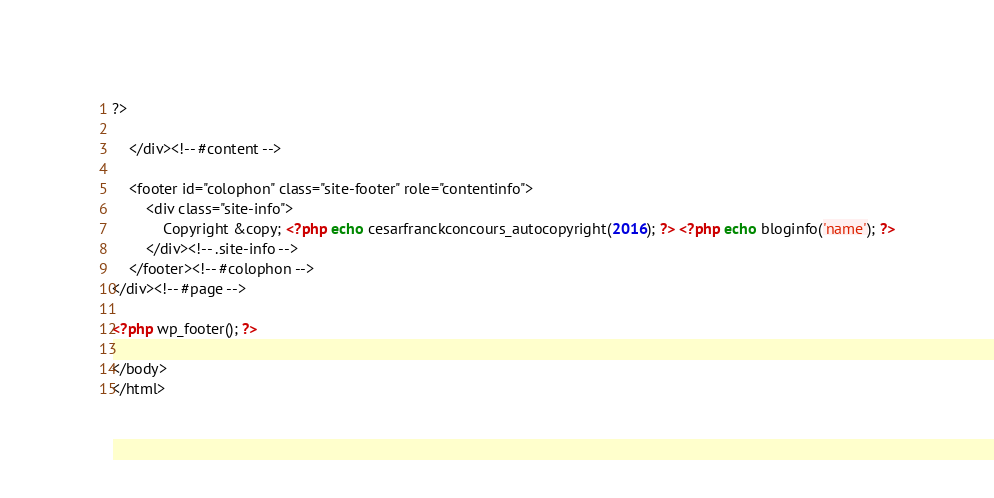Convert code to text. <code><loc_0><loc_0><loc_500><loc_500><_PHP_>
?>

	</div><!-- #content -->

	<footer id="colophon" class="site-footer" role="contentinfo">
		<div class="site-info">
			Copyright &copy; <?php echo cesarfranckconcours_autocopyright(2016); ?> <?php echo bloginfo('name'); ?>
		</div><!-- .site-info -->
	</footer><!-- #colophon -->
</div><!-- #page -->

<?php wp_footer(); ?>

</body>
</html>
</code> 